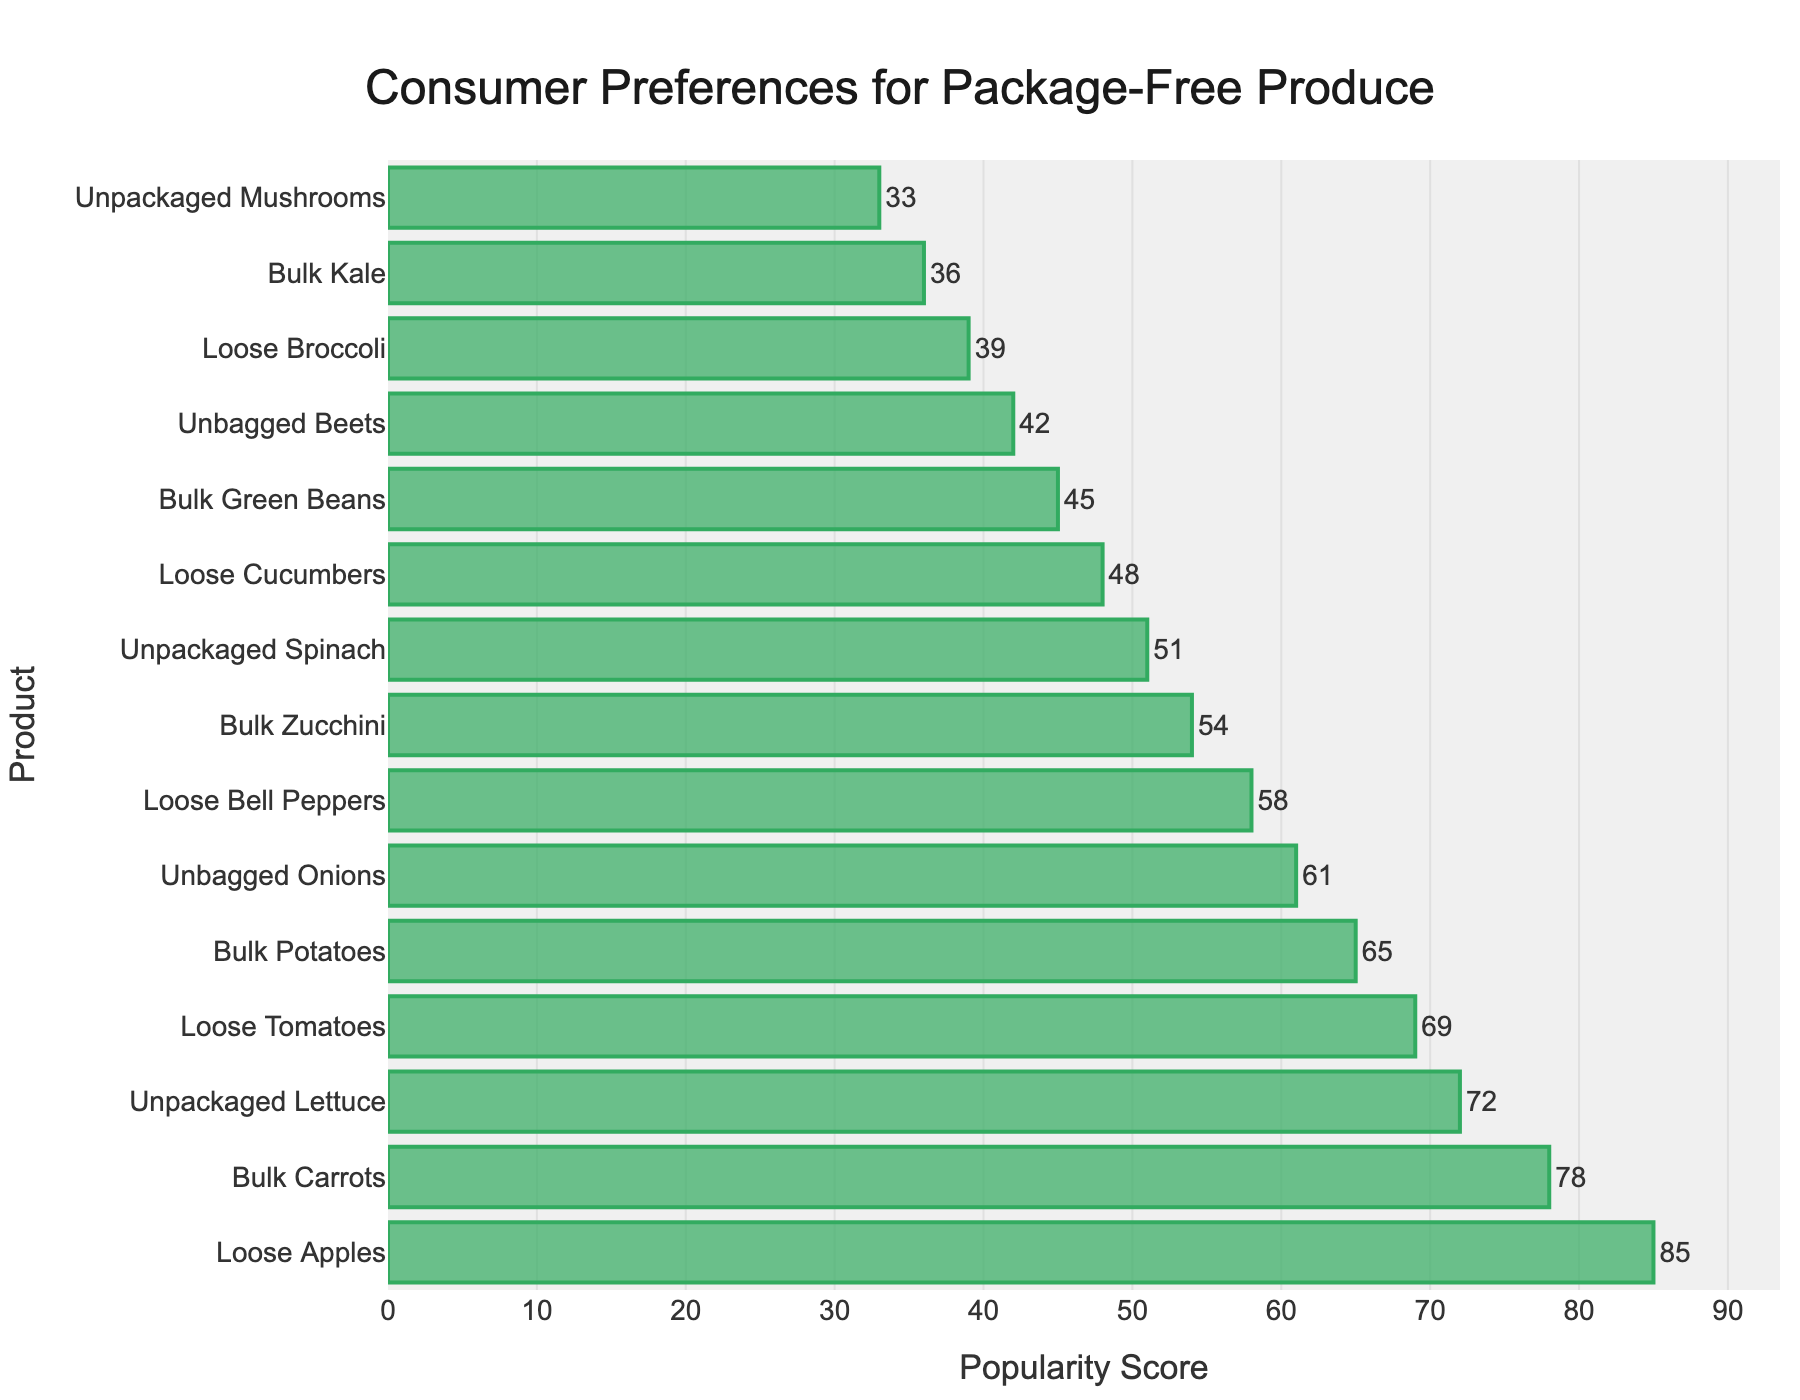What is the most preferred package-free produce option? The highest bar on the chart corresponds to "Loose Apples" with a popularity score of 85, making it the most preferred option.
Answer: Loose Apples What is the popularity score of Unbagged Onions? Find the "Unbagged Onions" label on the y-axis and trace it horizontally to the x-axis to see its popularity score of 61.
Answer: 61 Which product has a higher popularity score: Bulk Carrots or Loose Tomatoes? Compare the bars for "Bulk Carrots" and "Loose Tomatoes." "Bulk Carrots" has a score of 78, which is higher than "Loose Tomatoes" with a score of 69.
Answer: Bulk Carrots How many produce options have a popularity score greater than 70? Count the number of bars with values exceeding the 70 line. These are "Loose Apples," "Bulk Carrots," and "Unpackaged Lettuce": 3 options.
Answer: 3 What's the difference in popularity scores between the most and least popular package-free produce options? The highest score is for "Loose Apples" (85) and the lowest for "Unpackaged Mushrooms" (33). The difference is 85 - 33 = 52.
Answer: 52 What is the median popularity score of the produce options? Arrange the scores in ascending order: 33, 36, 39, 42, 45, 48, 51, 54, 58, 61, 65, 69, 72, 78, 85. The middle score in this ordered list, which is the 8th value, is 54.
Answer: 54 Which produce options are less popular than Loose Bell Peppers? "Loose Bell Peppers" has a score of 58. Products with lower scores include "Bulk Zucchini," "Unpackaged Spinach," "Loose Cucumbers," "Bulk Green Beans," "Unbagged Beets," "Loose Broccoli," "Bulk Kale," and "Unpackaged Mushrooms."
Answer: Bulk Zucchini, Unpackaged Spinach, Loose Cucumbers, Bulk Green Beans, Unbagged Beets, Loose Broccoli, Bulk Kale, Unpackaged Mushrooms What is the total popularity score of all produce options? Sum all the popularity scores: 85 + 78 + 72 + 69 + 65 + 61 + 58 + 54 + 51 + 48 + 45 + 42 + 39 + 36 + 33 = 836.
Answer: 836 How do the popularity scores of Loose Apples and Bulk Potatoes differ? "Loose Apples" has a score of 85, and "Bulk Potatoes" has a score of 65. The difference is 85 - 65 = 20.
Answer: 20 Which produce option is second most popular? The second-longest bar represents "Bulk Carrots" with a popularity score of 78.
Answer: Bulk Carrots 